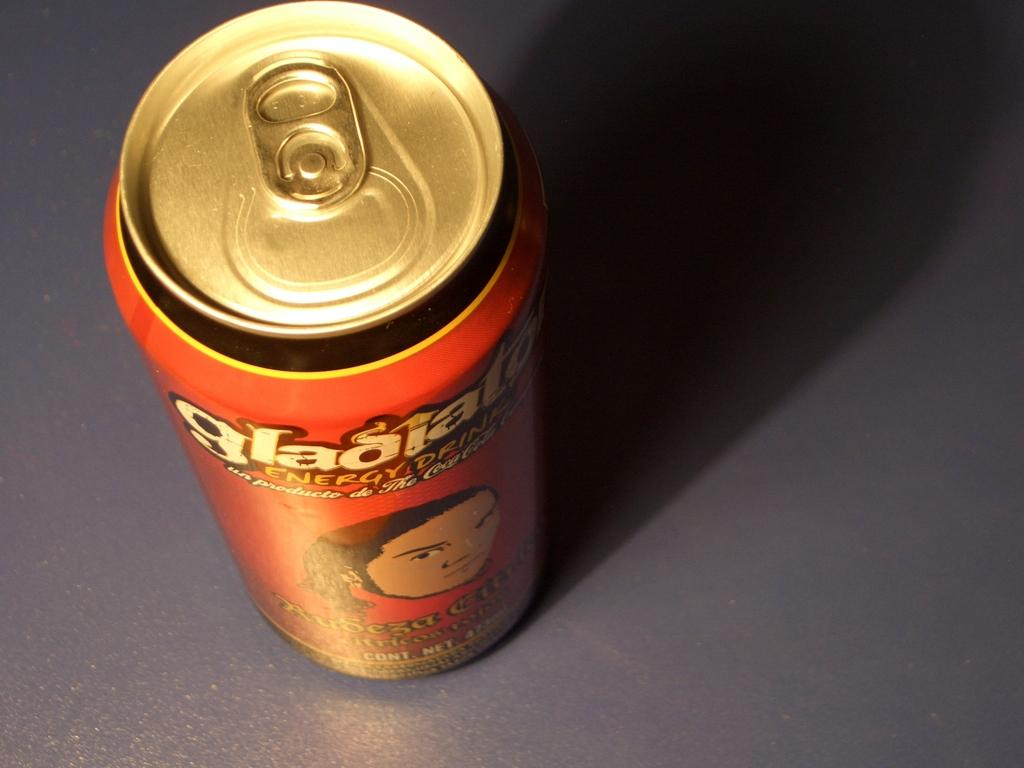<image>
Summarize the visual content of the image. An orange can has an illusratated face on the front. 